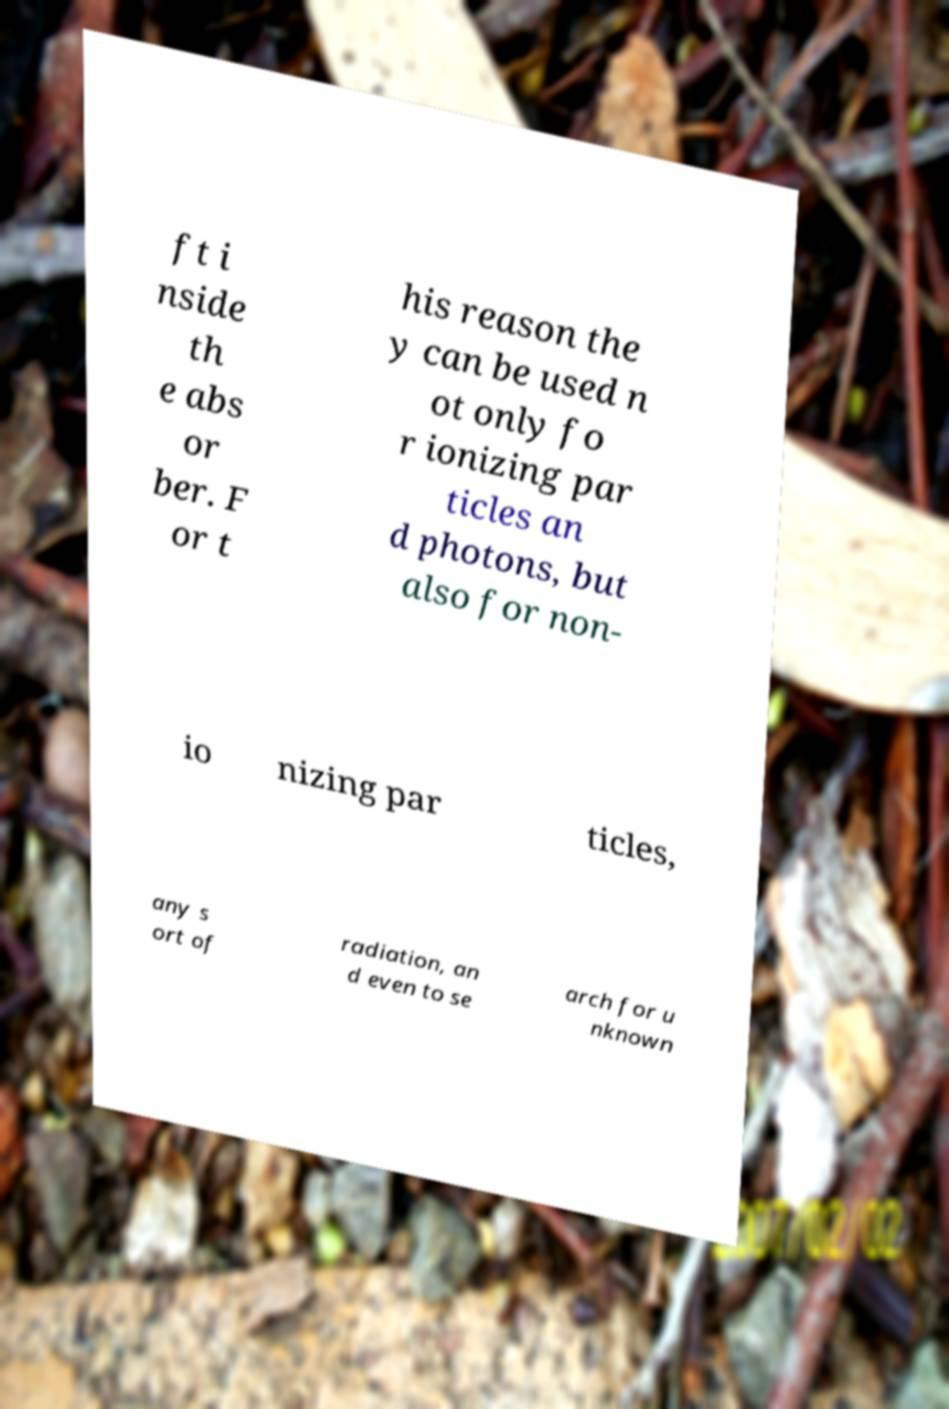I need the written content from this picture converted into text. Can you do that? ft i nside th e abs or ber. F or t his reason the y can be used n ot only fo r ionizing par ticles an d photons, but also for non- io nizing par ticles, any s ort of radiation, an d even to se arch for u nknown 